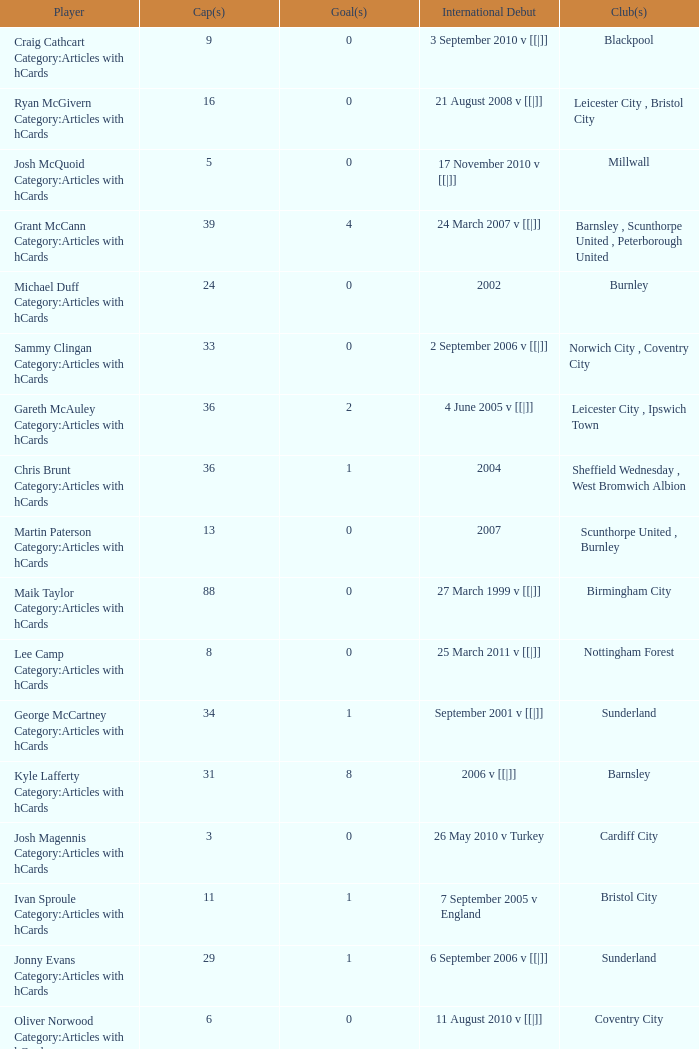How many caps figures are there for Norwich City, Coventry City? 1.0. 